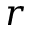Convert formula to latex. <formula><loc_0><loc_0><loc_500><loc_500>r</formula> 